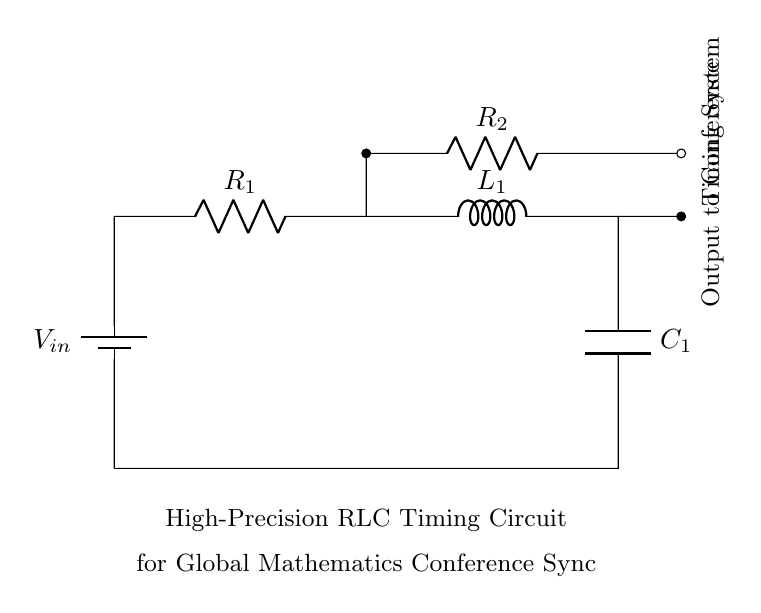What type of components are present in this circuit? The circuit includes a resistor, an inductor, and a capacitor. These components are essential for an RLC circuit, which is evidenced by their labels in the diagram.
Answer: Resistor, inductor, capacitor What is the role of the battery in the circuit? The battery provides the input voltage to the circuit, allowing electrical current to flow through the components. Its position at the start of the circuit indicates it as the source of electrical energy.
Answer: Input voltage source What is the type of circuit shown? This circuit is specifically a high-precision RLC timing circuit. This is indicated by the title labeled underneath the circuit, which describes its purpose in relation to synchronizing conference presentations.
Answer: High-precision RLC timing circuit What is connected to the output of the circuit? The output of the circuit connects to a timing system for conference synchronization. The labeling on the right side of the circuit diagram indicates the purpose of this output connection.
Answer: Timing system How does the resistance affect the oscillation frequency in an RLC circuit? The resistance in an RLC circuit influences the damping of the oscillations, affecting their frequency and amplitude. Higher resistance tends to dampen oscillations more, while lower resistance allows for higher oscillation frequency. This relationship is understood by analyzing the RLC circuit dynamics, though the exact values are not provided in this diagram.
Answer: Damps oscillations What is the significance of the capacitor in this RLC circuit configuration? The capacitor stores electrical energy in an electric field and is crucial for creating oscillations in the circuit. Its presence allows the circuit to resonate at a particular frequency, which is necessary for timing applications in synchronization processes.
Answer: Creates oscillations Which component is responsible for the timing aspect of the circuit? The inductor and capacitor together define the timing characteristics by forming a resonant circuit, while the resistor influences the rate at which energy is exchanged between these two components. Their interaction determines the overall timing behavior of the system.
Answer: Inductor and capacitor 